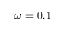<formula> <loc_0><loc_0><loc_500><loc_500>\omega = 0 . 1</formula> 